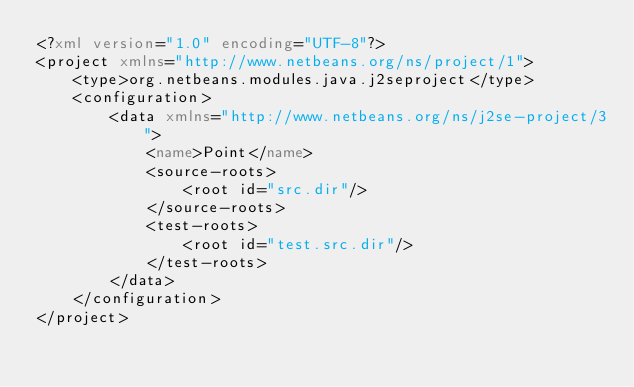Convert code to text. <code><loc_0><loc_0><loc_500><loc_500><_XML_><?xml version="1.0" encoding="UTF-8"?>
<project xmlns="http://www.netbeans.org/ns/project/1">
    <type>org.netbeans.modules.java.j2seproject</type>
    <configuration>
        <data xmlns="http://www.netbeans.org/ns/j2se-project/3">
            <name>Point</name>
            <source-roots>
                <root id="src.dir"/>
            </source-roots>
            <test-roots>
                <root id="test.src.dir"/>
            </test-roots>
        </data>
    </configuration>
</project>
</code> 